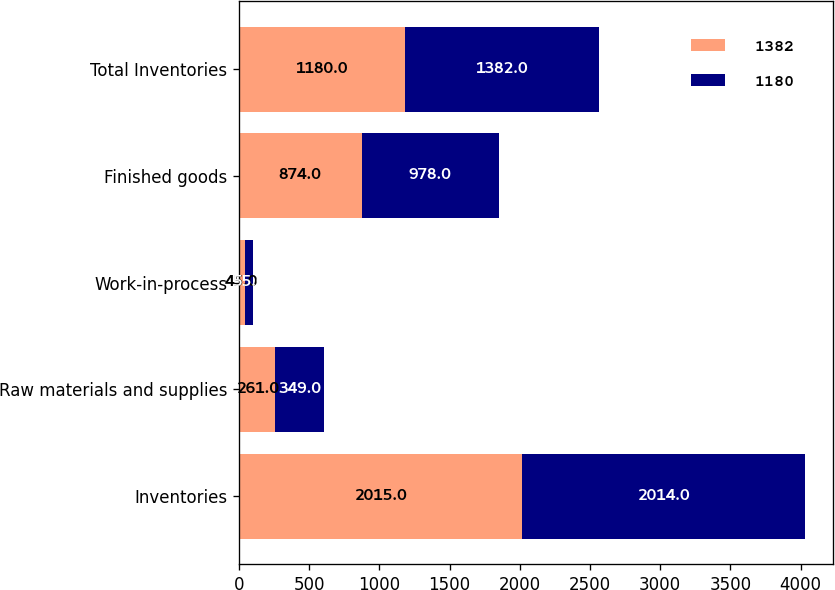Convert chart to OTSL. <chart><loc_0><loc_0><loc_500><loc_500><stacked_bar_chart><ecel><fcel>Inventories<fcel>Raw materials and supplies<fcel>Work-in-process<fcel>Finished goods<fcel>Total Inventories<nl><fcel>1382<fcel>2015<fcel>261<fcel>45<fcel>874<fcel>1180<nl><fcel>1180<fcel>2014<fcel>349<fcel>55<fcel>978<fcel>1382<nl></chart> 